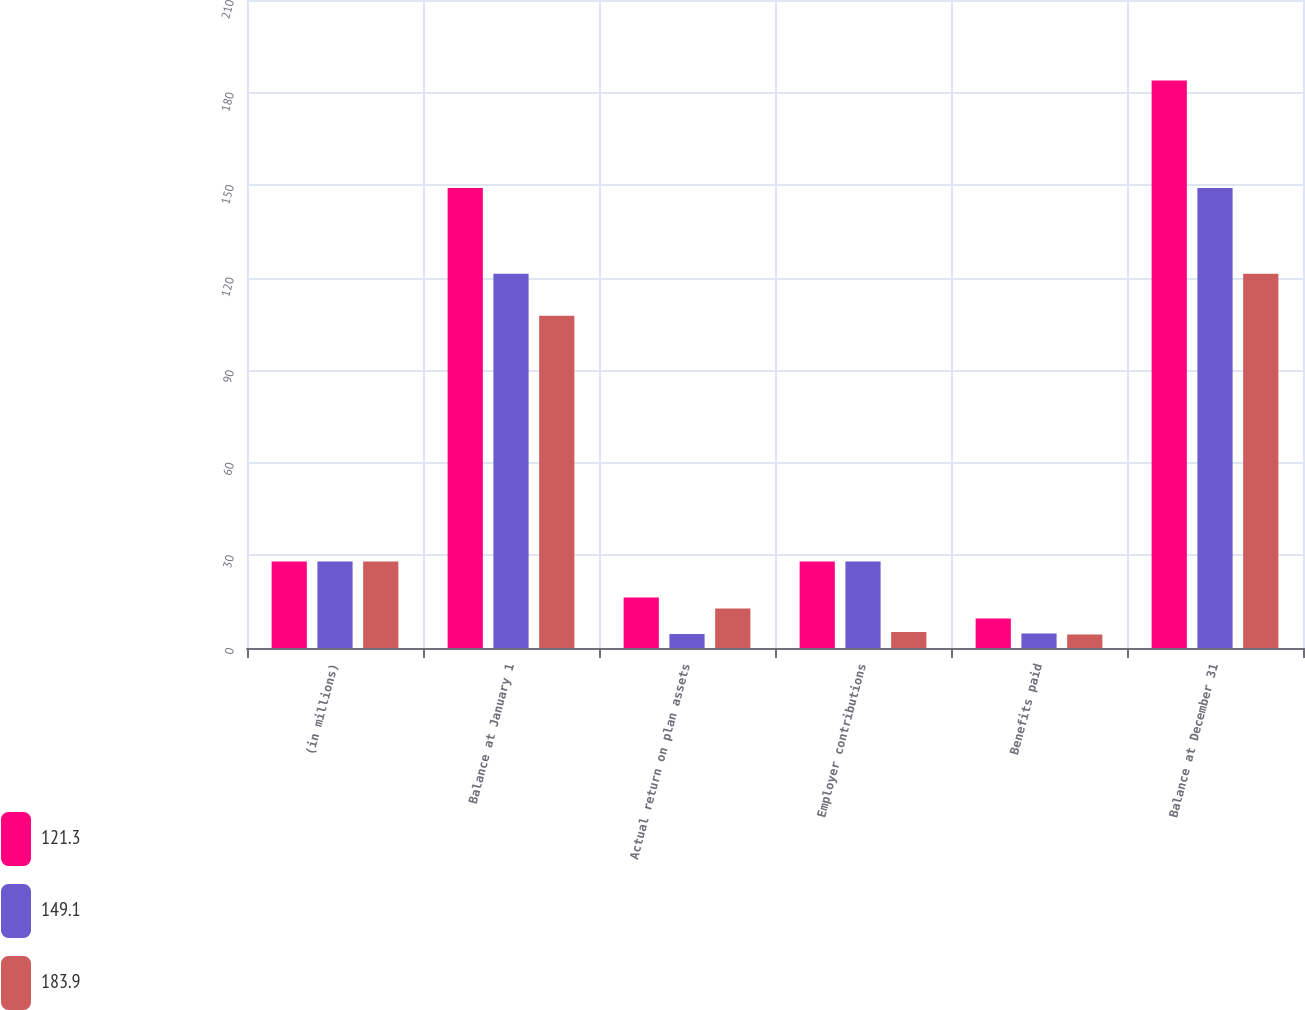Convert chart. <chart><loc_0><loc_0><loc_500><loc_500><stacked_bar_chart><ecel><fcel>(in millions)<fcel>Balance at January 1<fcel>Actual return on plan assets<fcel>Employer contributions<fcel>Benefits paid<fcel>Balance at December 31<nl><fcel>121.3<fcel>28<fcel>149.1<fcel>16.4<fcel>28<fcel>9.6<fcel>183.9<nl><fcel>149.1<fcel>28<fcel>121.3<fcel>4.5<fcel>28<fcel>4.7<fcel>149.1<nl><fcel>183.9<fcel>28<fcel>107.7<fcel>12.8<fcel>5.2<fcel>4.4<fcel>121.3<nl></chart> 